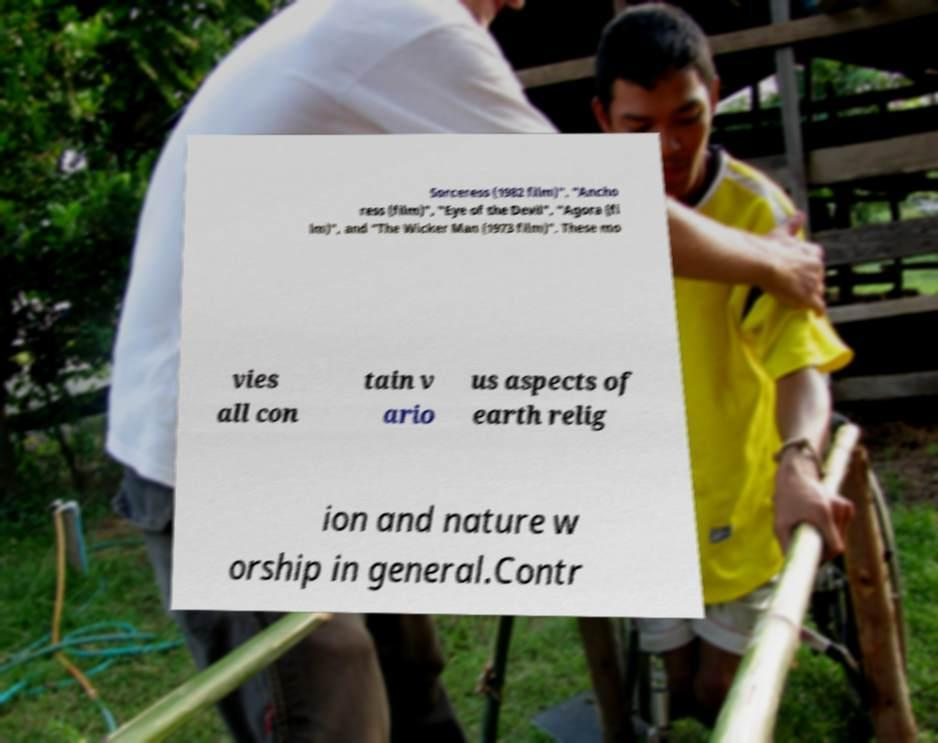Can you accurately transcribe the text from the provided image for me? Sorceress (1982 film)", "Ancho ress (film)", "Eye of the Devil", "Agora (fi lm)", and "The Wicker Man (1973 film)". These mo vies all con tain v ario us aspects of earth relig ion and nature w orship in general.Contr 